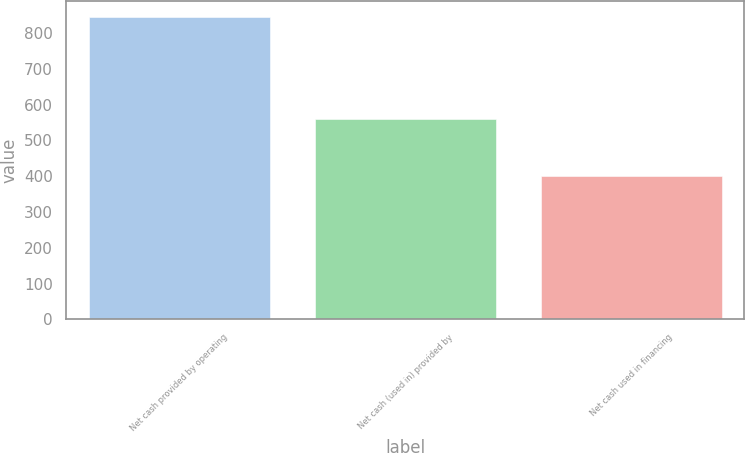Convert chart. <chart><loc_0><loc_0><loc_500><loc_500><bar_chart><fcel>Net cash provided by operating<fcel>Net cash (used in) provided by<fcel>Net cash used in financing<nl><fcel>845.9<fcel>561<fcel>401.7<nl></chart> 